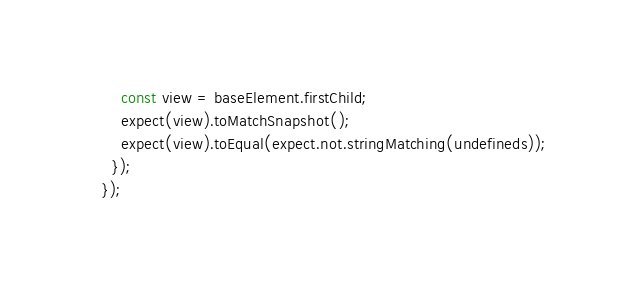Convert code to text. <code><loc_0><loc_0><loc_500><loc_500><_JavaScript_>    const view = baseElement.firstChild;
    expect(view).toMatchSnapshot();
    expect(view).toEqual(expect.not.stringMatching(undefineds));
  });
});
</code> 